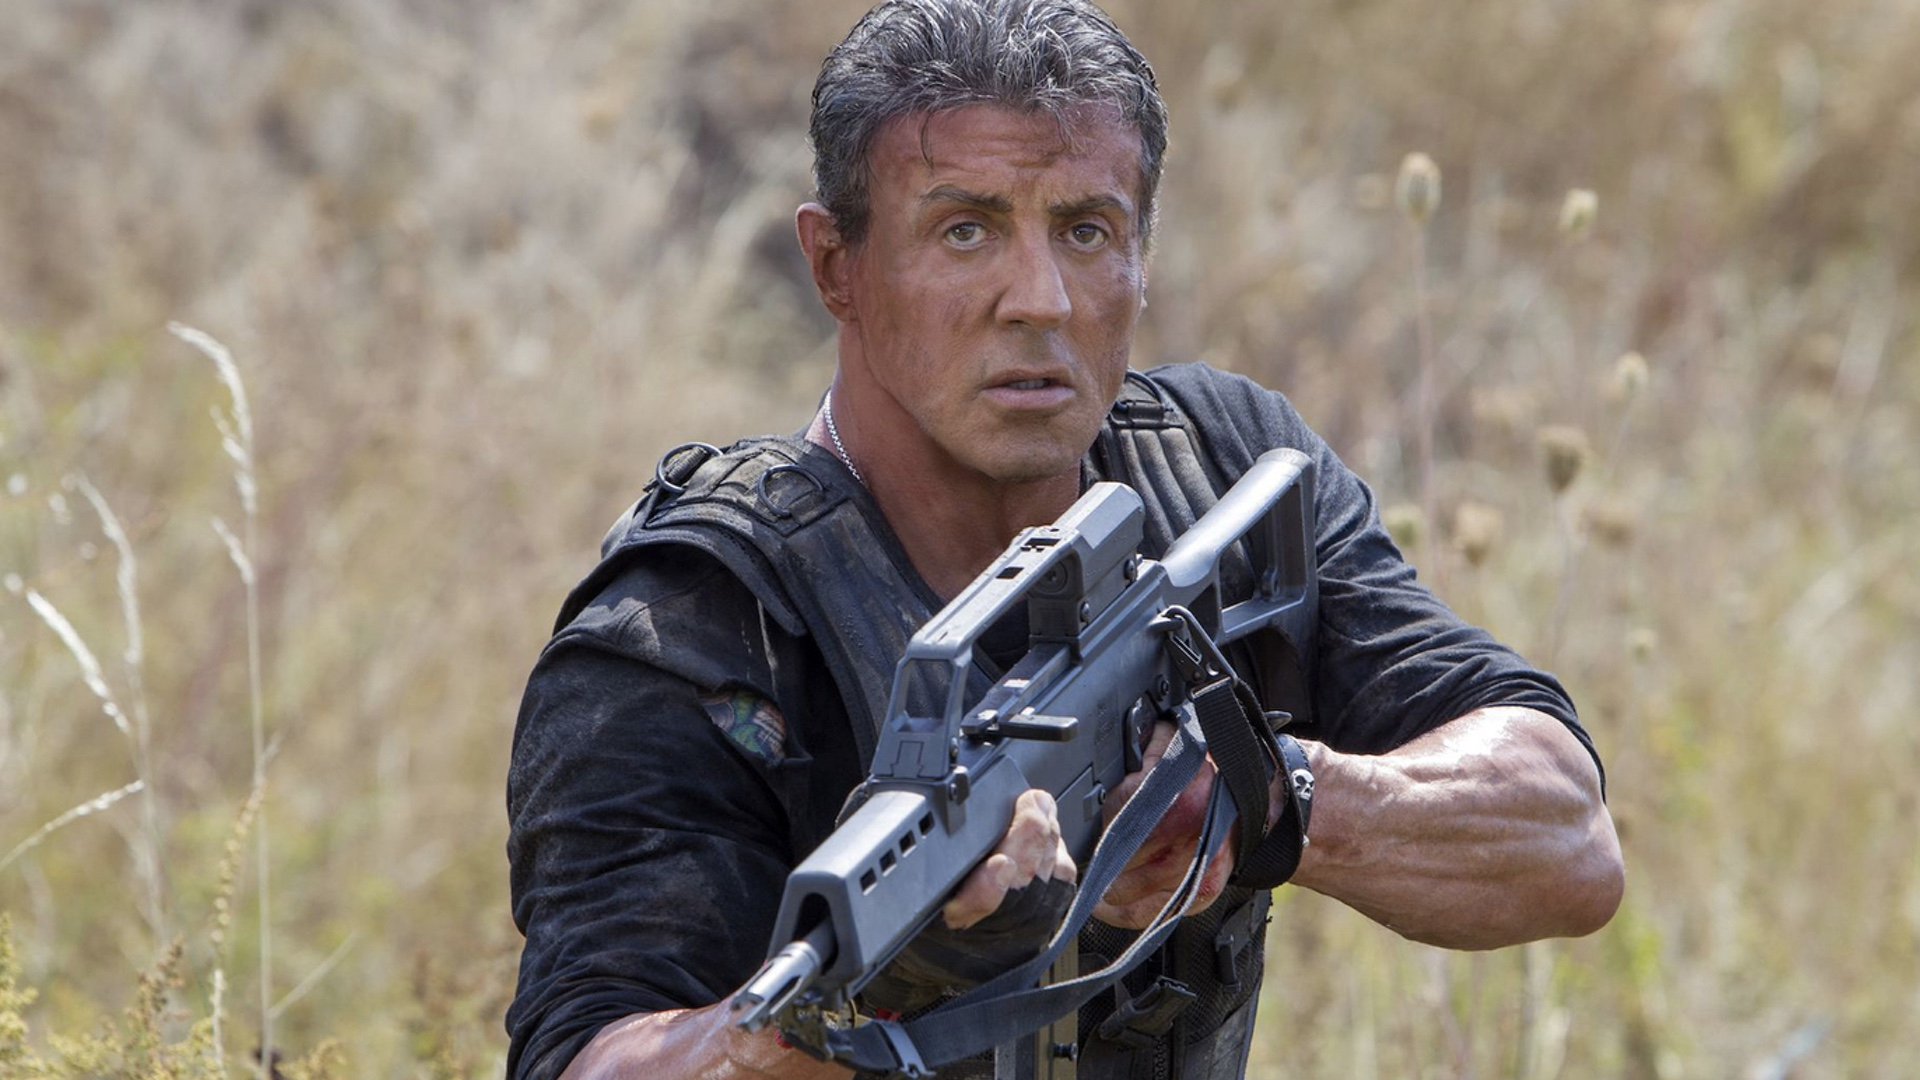What could be a long, realistic scenario for this situation? The character is a special forces operative tasked with infiltrating enemy territory to gather intelligence on a high-ranking adversary. After days of navigating through hostile landscapes, he arrives at this field, a strategic location suspected to be near the enemy's temporary base. The operative must remain hidden and silent, using the cover of tall grass and wildflowers to his advantage, while he observes enemy movements and sends vital information back to his team. Every minute is fraught with danger as he knows discovery could lead to a deadly confrontation. As dusk approaches, he prepares for the final leg of his mission, understanding that the success of his operation is critical to the broader campaign and could potentially save countless lives. 